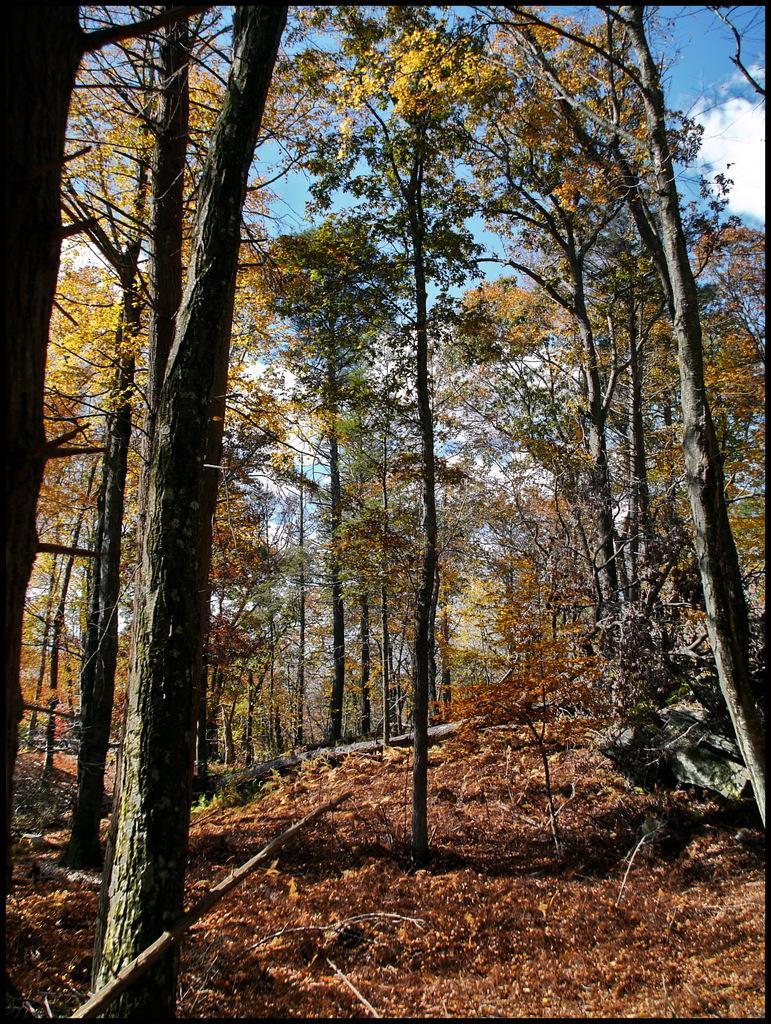Could you give a brief overview of what you see in this image? In the image there are many trees. And on the ground there are leaves. In the background there is a sky with clouds. 